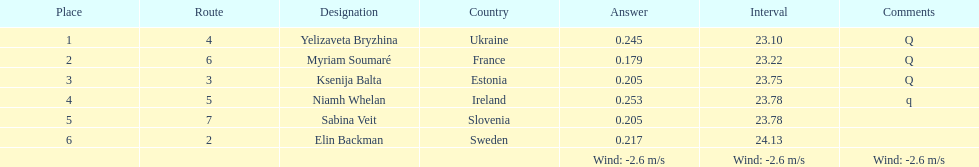Are any of the lanes in successive order? No. 